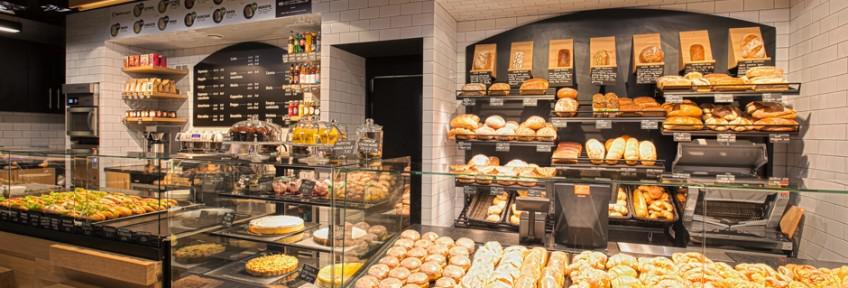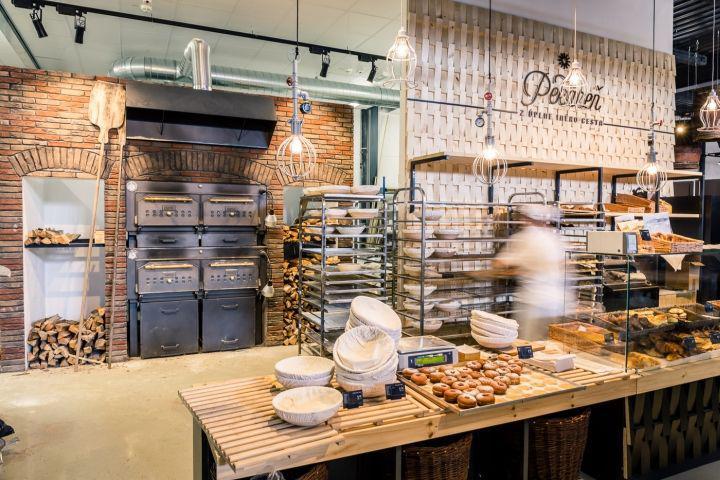The first image is the image on the left, the second image is the image on the right. Examine the images to the left and right. Is the description "There are exactly five lights hanging above the counter in the image on the right." accurate? Answer yes or no. Yes. 